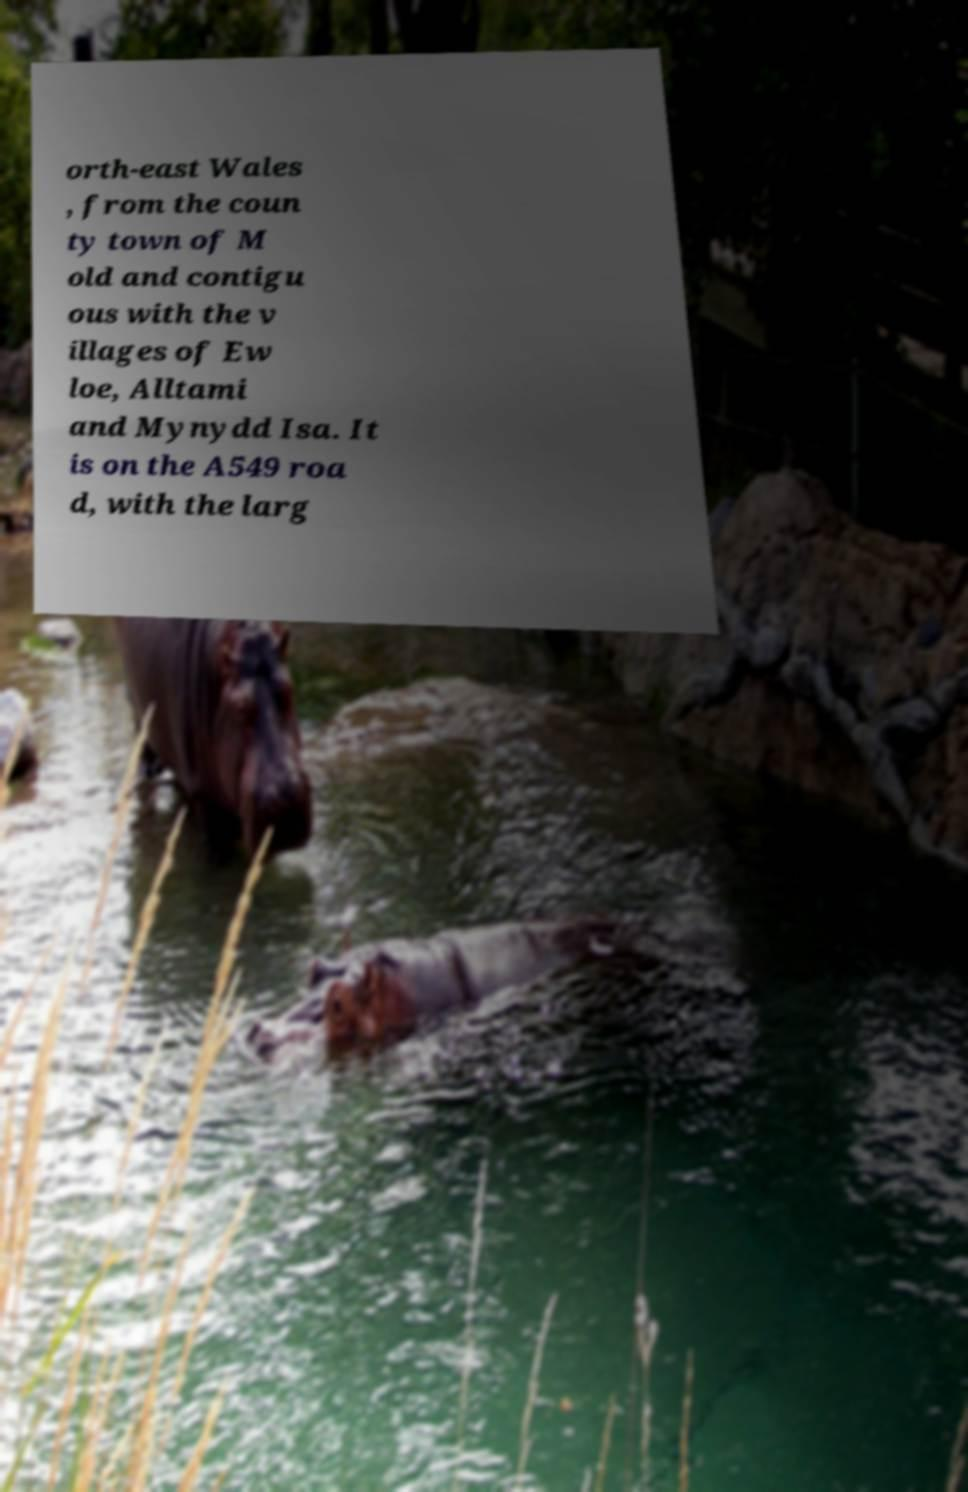Could you assist in decoding the text presented in this image and type it out clearly? orth-east Wales , from the coun ty town of M old and contigu ous with the v illages of Ew loe, Alltami and Mynydd Isa. It is on the A549 roa d, with the larg 